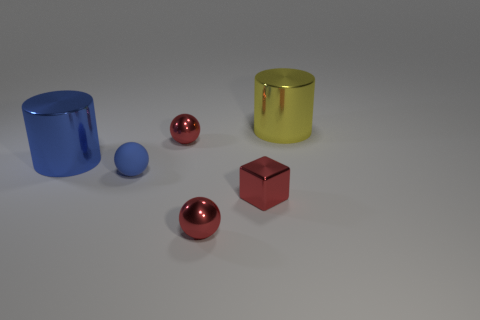Subtract all blue cubes. How many red balls are left? 2 Subtract all metallic balls. How many balls are left? 1 Add 2 small red metal balls. How many objects exist? 8 Subtract all balls. Subtract all large yellow cylinders. How many objects are left? 2 Add 5 blue metallic cylinders. How many blue metallic cylinders are left? 6 Add 3 large brown metal cylinders. How many large brown metal cylinders exist? 3 Subtract 1 red cubes. How many objects are left? 5 Subtract all blocks. How many objects are left? 5 